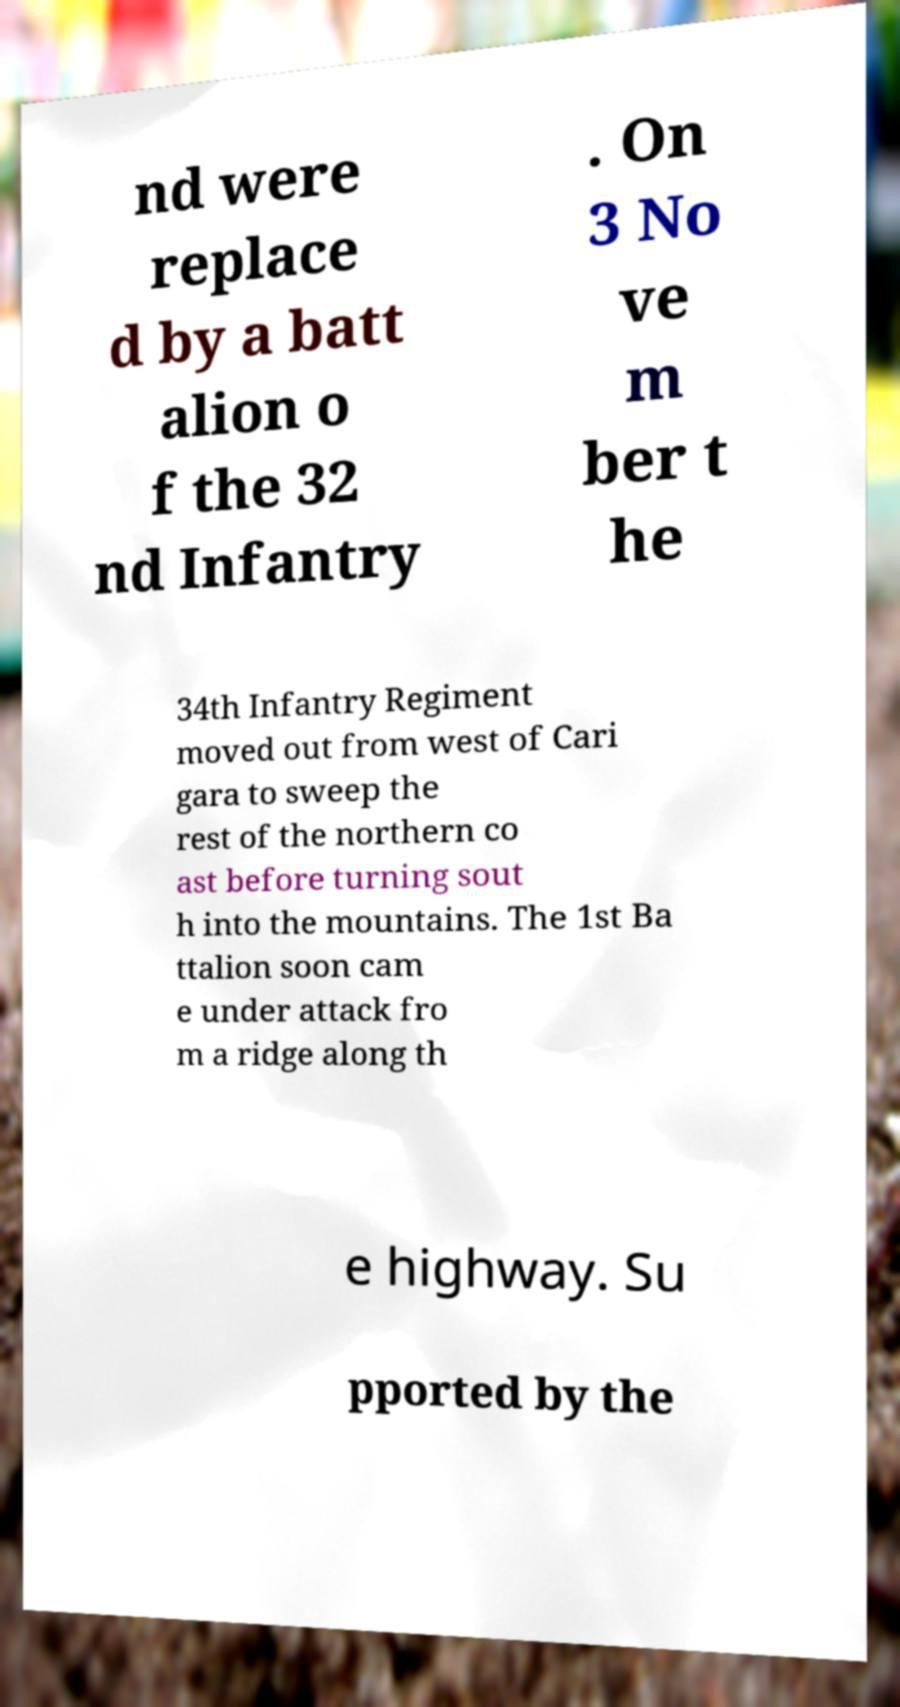Please identify and transcribe the text found in this image. nd were replace d by a batt alion o f the 32 nd Infantry . On 3 No ve m ber t he 34th Infantry Regiment moved out from west of Cari gara to sweep the rest of the northern co ast before turning sout h into the mountains. The 1st Ba ttalion soon cam e under attack fro m a ridge along th e highway. Su pported by the 